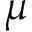Convert formula to latex. <formula><loc_0><loc_0><loc_500><loc_500>\mu</formula> 